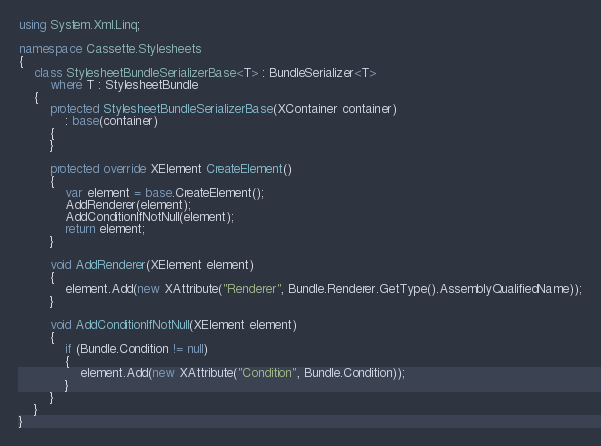<code> <loc_0><loc_0><loc_500><loc_500><_C#_>using System.Xml.Linq;

namespace Cassette.Stylesheets
{
    class StylesheetBundleSerializerBase<T> : BundleSerializer<T>
        where T : StylesheetBundle
    {
        protected StylesheetBundleSerializerBase(XContainer container)
            : base(container)
        {
        }

        protected override XElement CreateElement()
        {
            var element = base.CreateElement();
            AddRenderer(element);
            AddConditionIfNotNull(element);
            return element;
        }

        void AddRenderer(XElement element)
        {
            element.Add(new XAttribute("Renderer", Bundle.Renderer.GetType().AssemblyQualifiedName));
        }

        void AddConditionIfNotNull(XElement element)
        {
            if (Bundle.Condition != null)
            {
                element.Add(new XAttribute("Condition", Bundle.Condition));
            }
        }
    }
}</code> 